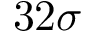Convert formula to latex. <formula><loc_0><loc_0><loc_500><loc_500>3 2 \sigma</formula> 